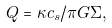Convert formula to latex. <formula><loc_0><loc_0><loc_500><loc_500>Q = \kappa c _ { s } / \pi G \Sigma ,</formula> 